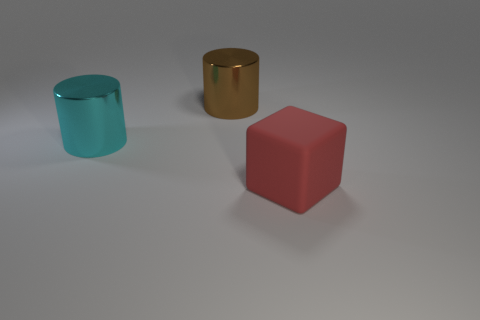Subtract 0 blue cylinders. How many objects are left? 3 Subtract all cylinders. How many objects are left? 1 Subtract 1 cylinders. How many cylinders are left? 1 Subtract all blue cylinders. Subtract all blue balls. How many cylinders are left? 2 Subtract all brown balls. How many blue blocks are left? 0 Subtract all brown things. Subtract all rubber blocks. How many objects are left? 1 Add 1 large brown cylinders. How many large brown cylinders are left? 2 Add 3 big brown cylinders. How many big brown cylinders exist? 4 Add 2 big cyan shiny cylinders. How many objects exist? 5 Subtract all brown cylinders. How many cylinders are left? 1 